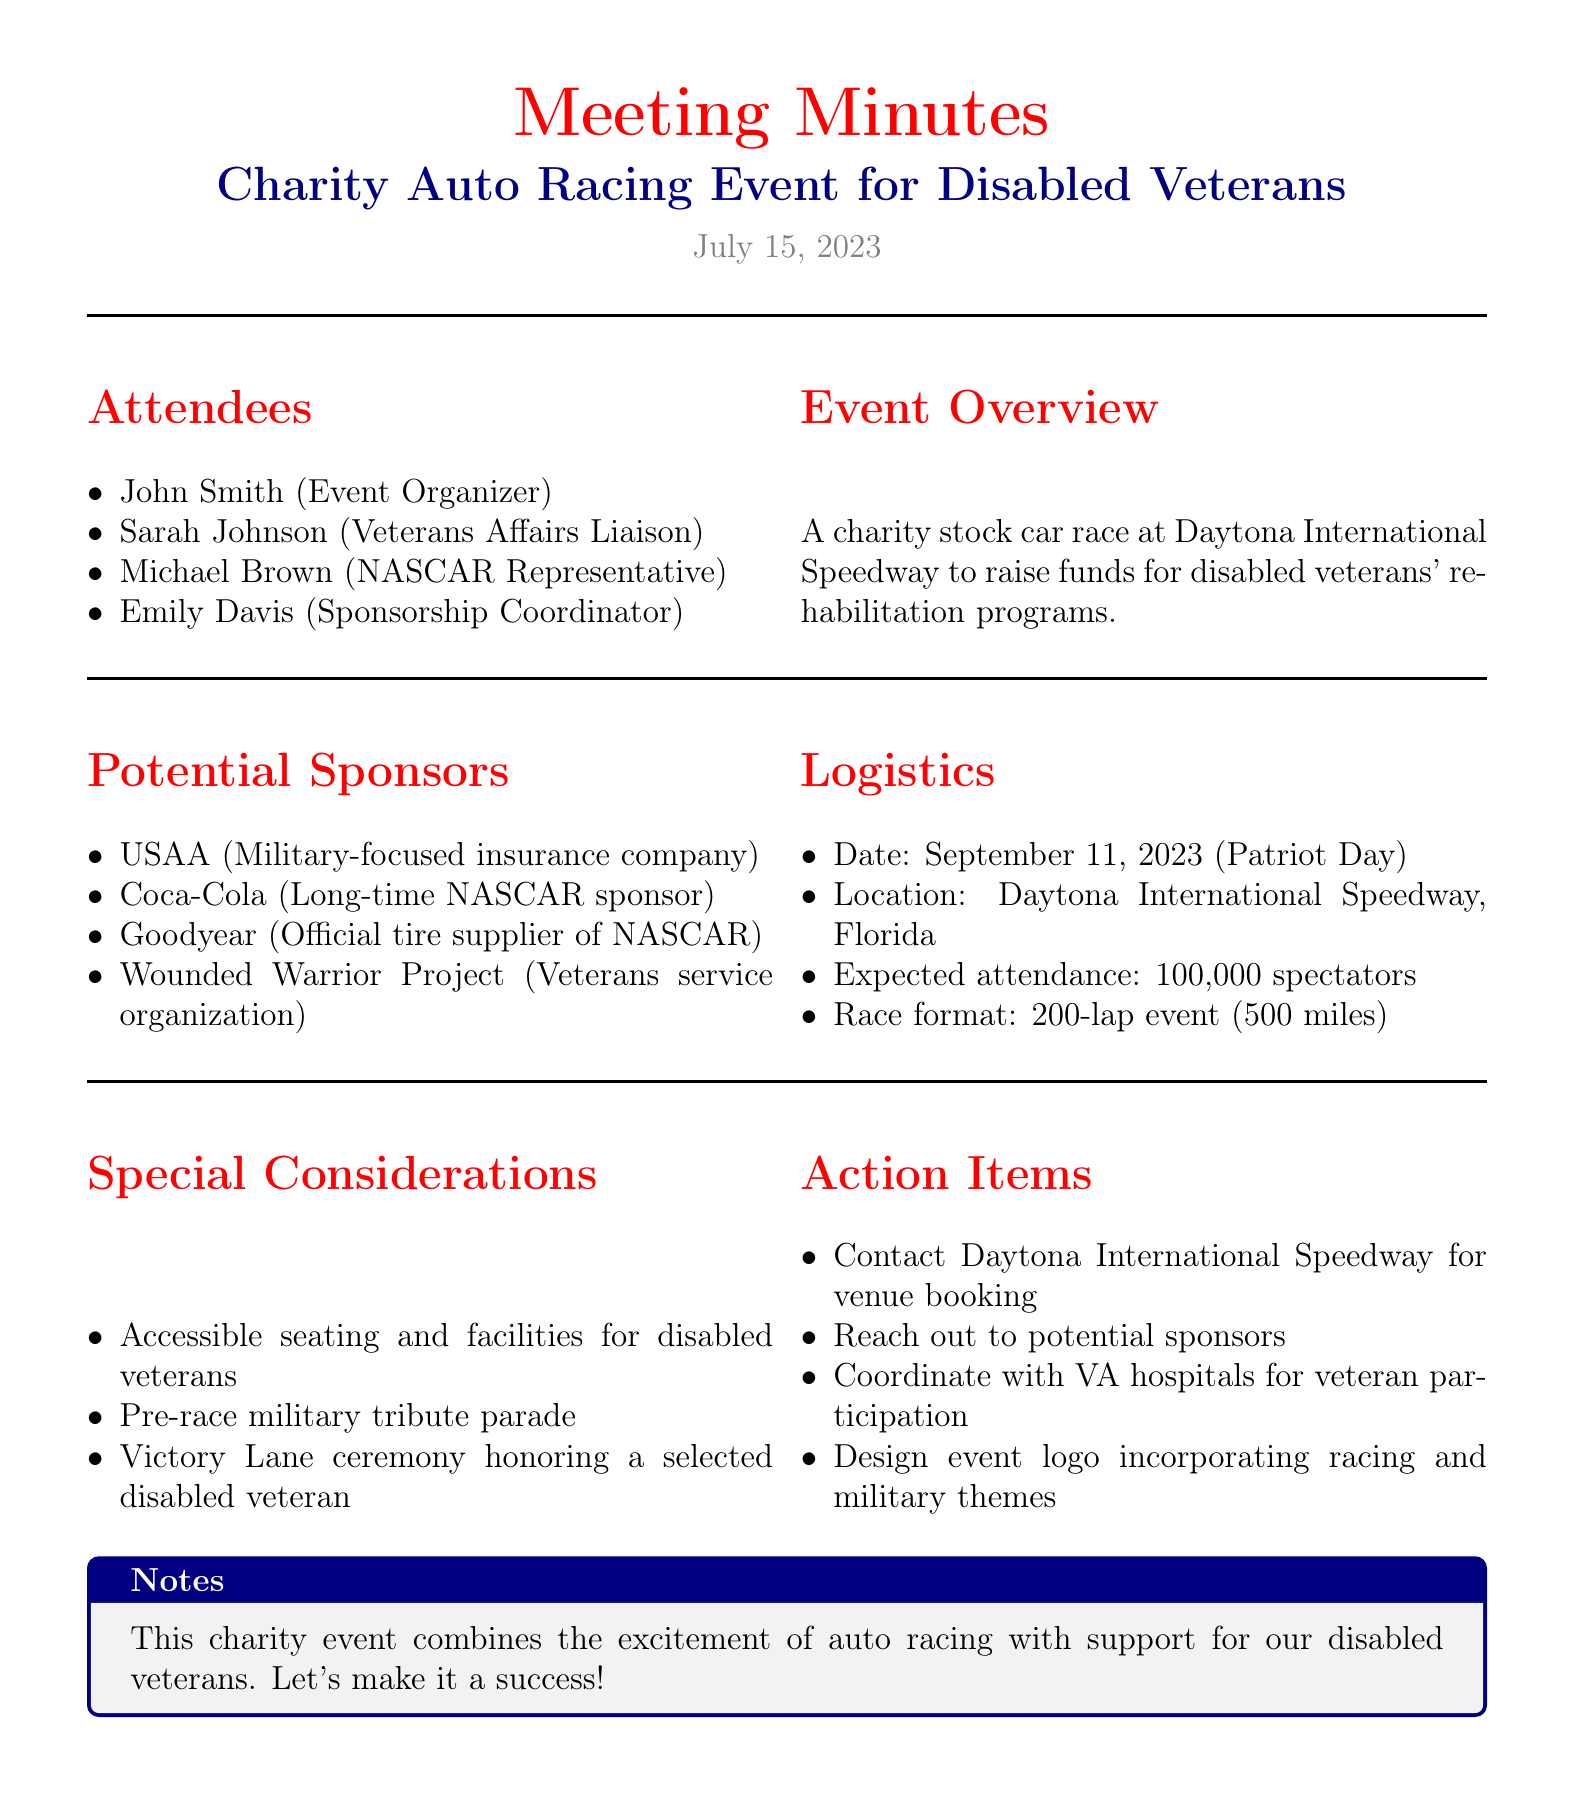What is the date of the event? The document states the event is scheduled for September 11, 2023.
Answer: September 11, 2023 Who is the Event Organizer? The meeting minutes list John Smith as the Event Organizer.
Answer: John Smith What is the expected attendance for the event? The document indicates the expected attendance is 100,000 spectators.
Answer: 100,000 spectators What is one of the potential sponsors mentioned? The document provides a list of potential sponsors including USAA, Coca-Cola, and others.
Answer: USAA What format will the race take? According to the logistics section, the race is a 200-lap event (500 miles).
Answer: 200-lap event (500 miles) What special consideration is mentioned for disabled veterans? The document highlights accessible seating and facilities as a special consideration.
Answer: Accessible seating and facilities What is one action item to be completed? The action items include several tasks, one being to contact Daytona International Speedway for venue booking.
Answer: Contact Daytona International Speedway for venue booking What is the location of the event? The logistics section specifies that the location of the event is Daytona International Speedway, Florida.
Answer: Daytona International Speedway, Florida What ceremony is planned to honor a disabled veteran? The document mentions a Victory Lane ceremony honoring a selected disabled veteran.
Answer: Victory Lane ceremony honoring a selected disabled veteran 